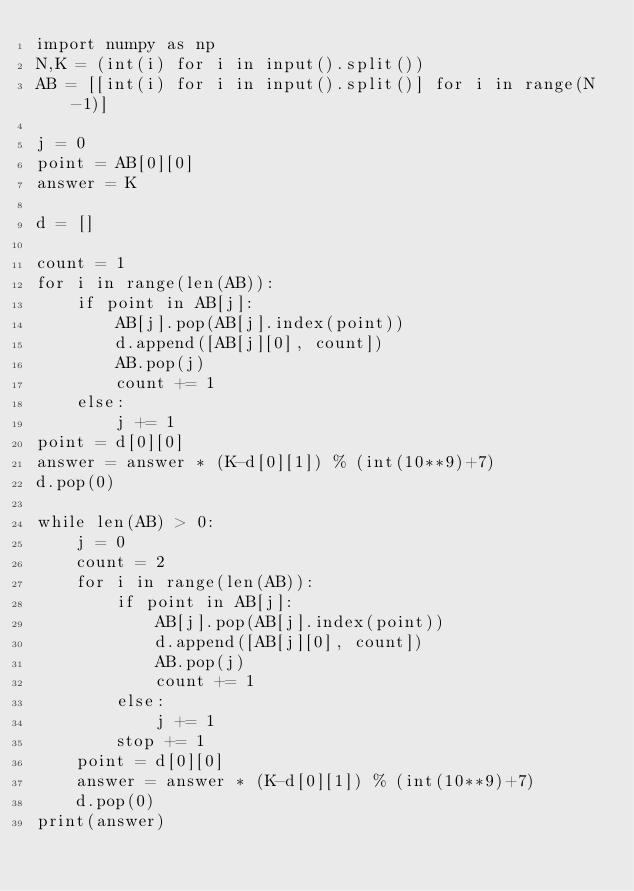Convert code to text. <code><loc_0><loc_0><loc_500><loc_500><_Python_>import numpy as np
N,K = (int(i) for i in input().split())  
AB = [[int(i) for i in input().split()] for i in range(N-1)] 

j = 0
point = AB[0][0]
answer = K

d = []

count = 1
for i in range(len(AB)):
    if point in AB[j]:
        AB[j].pop(AB[j].index(point))
        d.append([AB[j][0], count])
        AB.pop(j)
        count += 1
    else:
        j += 1
point = d[0][0]
answer = answer * (K-d[0][1]) % (int(10**9)+7)
d.pop(0)

while len(AB) > 0:
    j = 0
    count = 2
    for i in range(len(AB)):
        if point in AB[j]:
            AB[j].pop(AB[j].index(point))
            d.append([AB[j][0], count])
            AB.pop(j)
            count += 1
        else:
            j += 1
        stop += 1
    point = d[0][0]
    answer = answer * (K-d[0][1]) % (int(10**9)+7)
    d.pop(0)
print(answer)</code> 